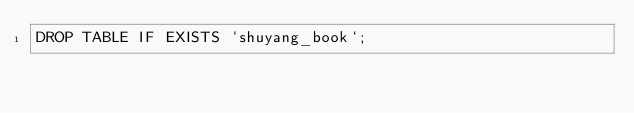<code> <loc_0><loc_0><loc_500><loc_500><_SQL_>DROP TABLE IF EXISTS `shuyang_book`;
</code> 